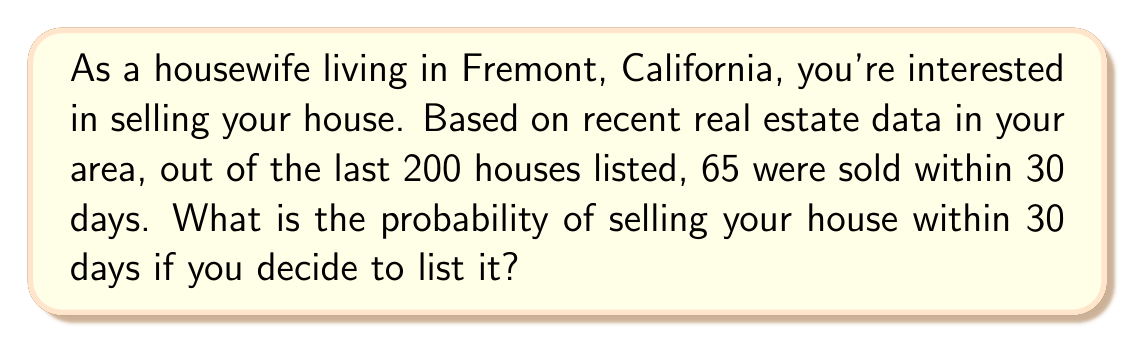Can you solve this math problem? To solve this problem, we need to use the concept of relative frequency as an estimate of probability. The probability of an event occurring can be estimated by dividing the number of favorable outcomes by the total number of possible outcomes.

Let's define our variables:
$n$ = total number of houses listed = 200
$k$ = number of houses sold within 30 days = 65

The probability $P$ of selling a house within 30 days can be calculated as:

$$P = \frac{k}{n} = \frac{65}{200}$$

To simplify this fraction:

$$P = \frac{65}{200} = \frac{13}{40} = 0.325$$

We can convert this to a percentage by multiplying by 100:

$$0.325 \times 100 = 32.5\%$$

Therefore, based on the historical data provided, there is approximately a 32.5% chance of selling your house within 30 days if you decide to list it.
Answer: $P(\text{selling within 30 days}) = 0.325$ or $32.5\%$ 